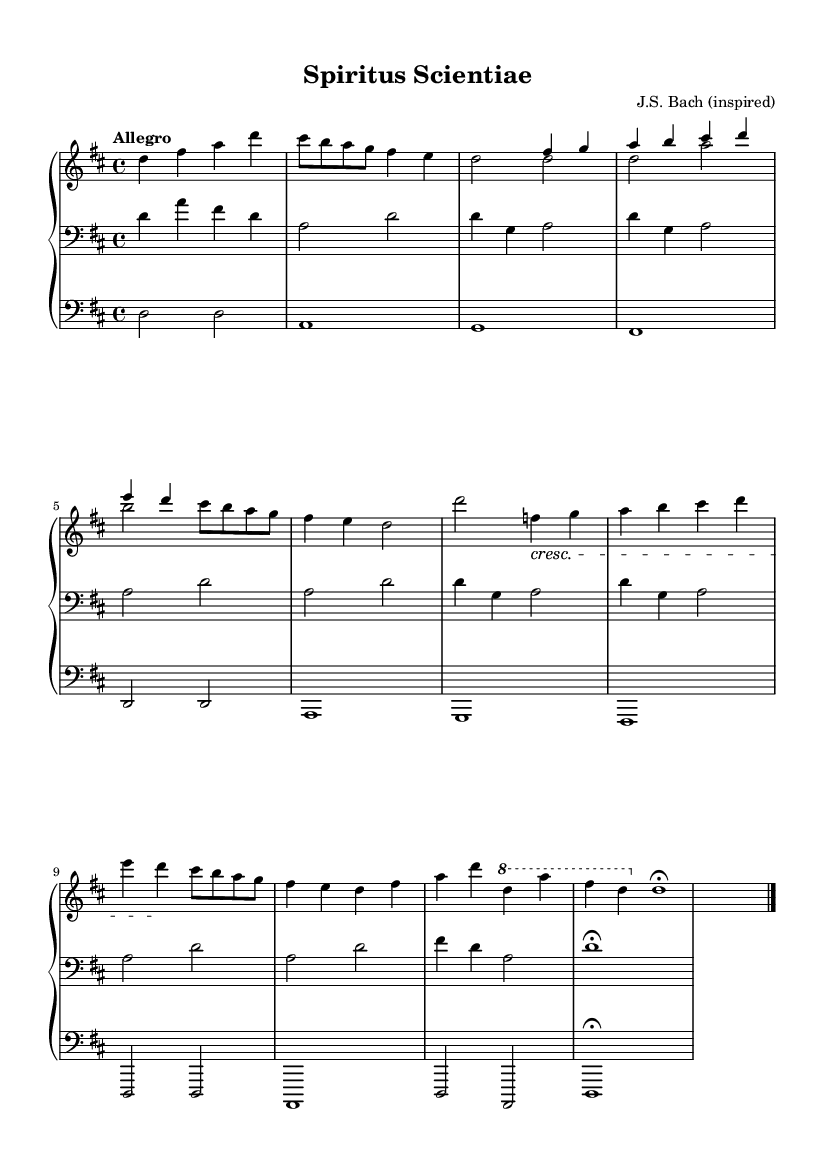What is the key signature of this music? The key signature is indicated by the sharps and flats at the beginning of the staff. In this case, it has two sharps, which corresponds to D major.
Answer: D major What is the time signature? The time signature is located at the beginning of the music, shown as a fraction. Here, it is 4 over 4, indicating four beats per measure.
Answer: 4/4 What is the tempo marking for this piece? The tempo marking is shown directly above the staff, indicating the speed at which to perform the music. Here it states "Allegro," which is a quick tempo.
Answer: Allegro How many sections are there in the composition? By examining the structure outlined in the music, we can see there are four labeled sections (Section A, Section B, Section C, Section A'').
Answer: Four What is a distinctive feature of Baroque music reflected in this composition? This composition includes contrapuntal elements, which is a characteristic of Baroque music, meaning multiple independent melodies are woven together.
Answer: Contrapuntal elements What is the dynamic marking used in the score? The score features a marking that indicates a gradual increase in volume, specifically labeled as "cresc," which stands for crescendo.
Answer: Crescendo What is the final note duration in the piece? Looking at the final measure, the last note has a fermata, indicating it is held longer than usual, and its notation shows it as a whole note (1).
Answer: Whole note 